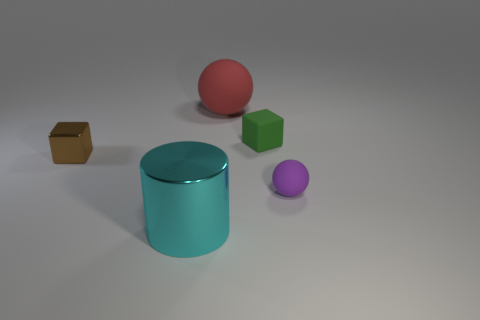There is a large object that is to the right of the big object that is on the left side of the big rubber object; are there any tiny green blocks on the right side of it?
Offer a terse response. Yes. There is a red sphere that is made of the same material as the tiny purple ball; what is its size?
Make the answer very short. Large. Are there any rubber things right of the big rubber sphere?
Your response must be concise. Yes. Is there a ball on the right side of the cube that is right of the big rubber ball?
Provide a succinct answer. Yes. There is a block right of the cyan cylinder; does it have the same size as the metal thing that is in front of the tiny brown metal thing?
Provide a succinct answer. No. How many large objects are either red matte cylinders or blocks?
Offer a very short reply. 0. What is the material of the ball to the left of the ball that is right of the rubber block?
Your response must be concise. Rubber. Is there a brown block made of the same material as the purple sphere?
Offer a terse response. No. Does the cyan cylinder have the same material as the purple sphere to the right of the small brown metallic object?
Provide a short and direct response. No. The sphere that is the same size as the brown metal cube is what color?
Ensure brevity in your answer.  Purple. 